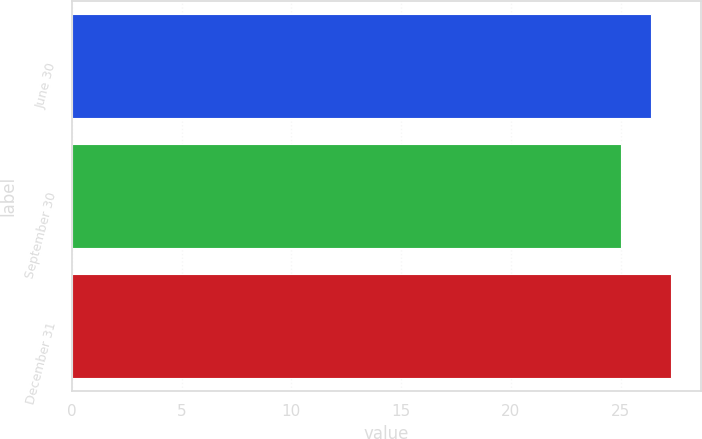<chart> <loc_0><loc_0><loc_500><loc_500><bar_chart><fcel>June 30<fcel>September 30<fcel>December 31<nl><fcel>26.4<fcel>25<fcel>27.3<nl></chart> 